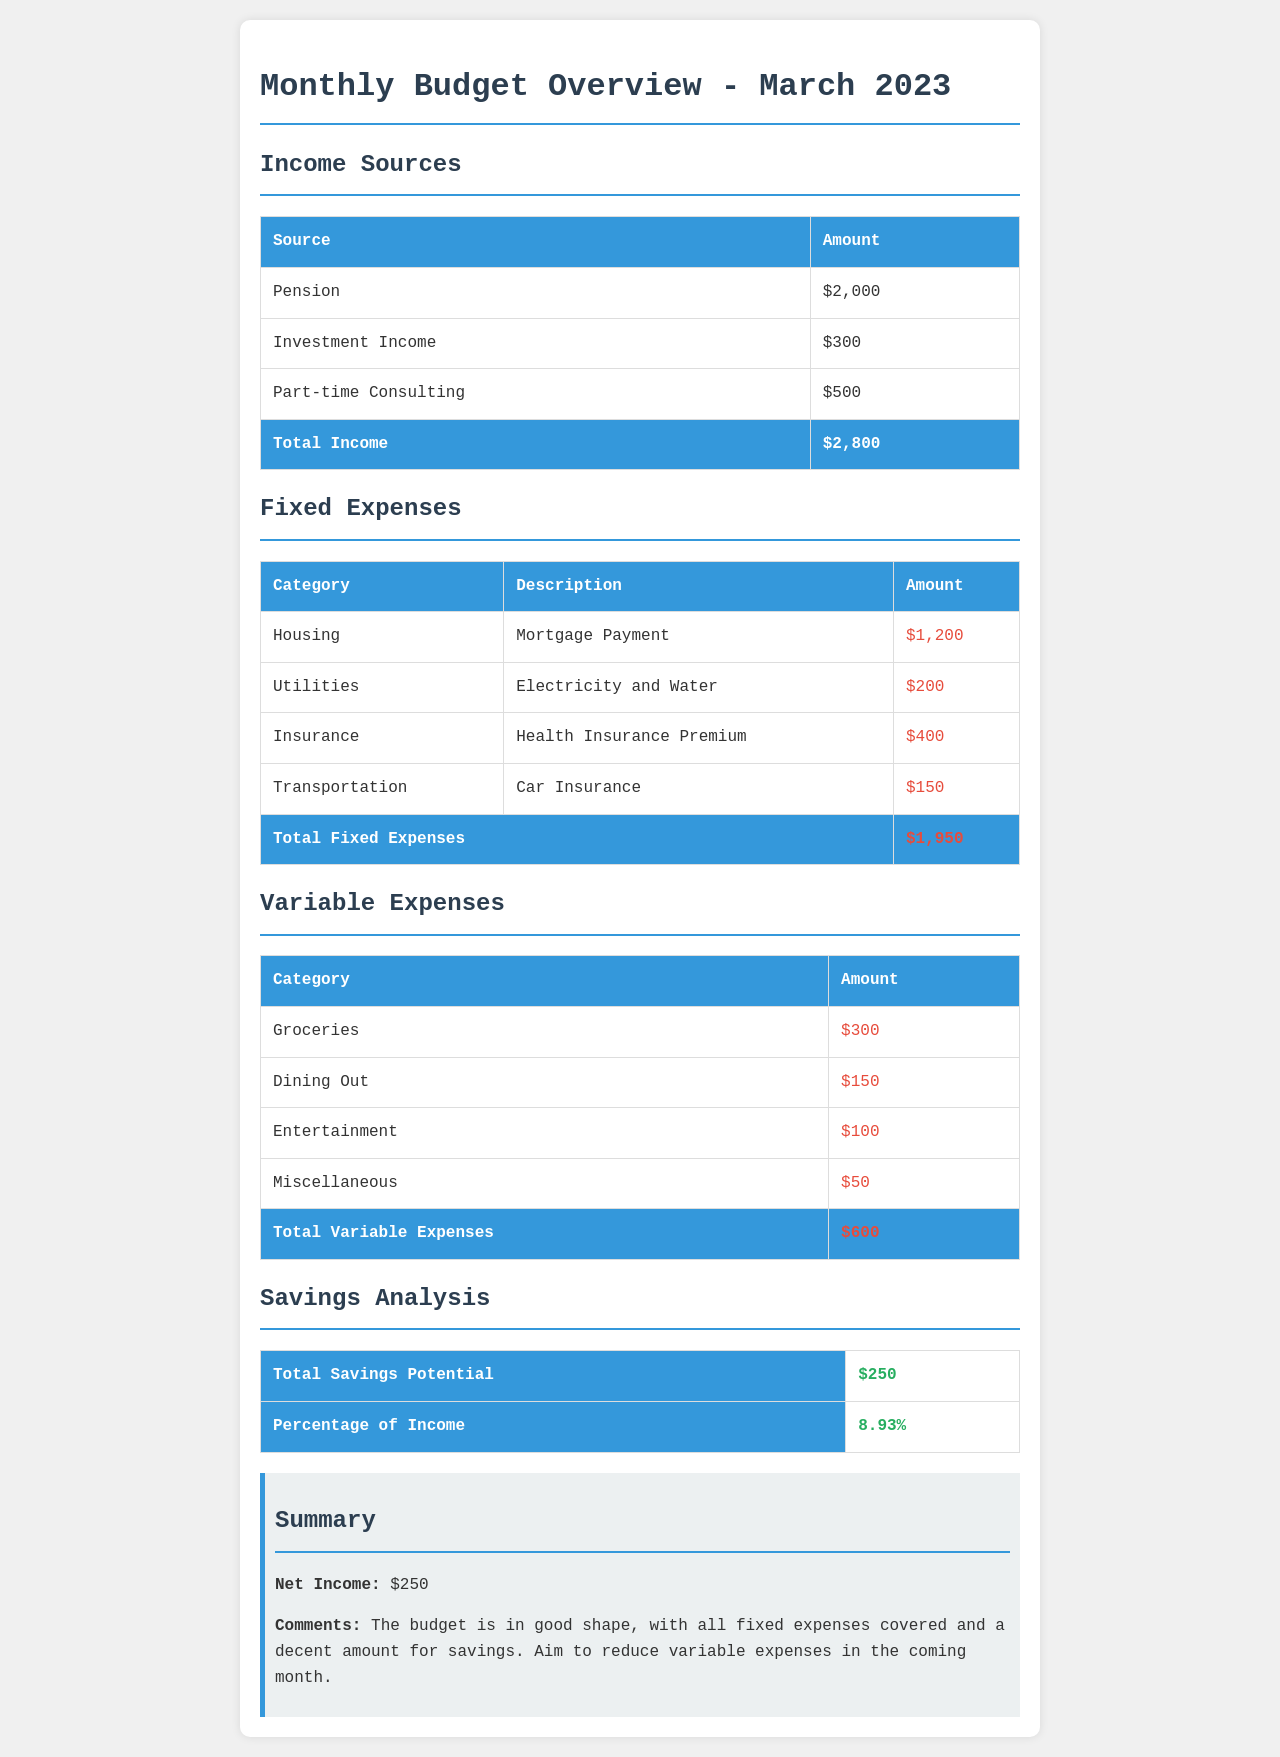What is the total income? The total income is the sum of all income sources in the document, which is $2000 + $300 + $500 = $2800.
Answer: $2800 What are the total fixed expenses? The total fixed expenses is the sum of all fixed expenses listed, which amounts to $1200 + $200 + $400 + $150 = $1950.
Answer: $1950 How much was spent on groceries? The document lists groceries as a variable expense with an amount of $300.
Answer: $300 What is the total savings potential? The document states that the total savings potential is $250.
Answer: $250 What is the percentage of income allocated to savings? The percentage of income for savings, as mentioned in the savings analysis, is 8.93%.
Answer: 8.93% What is the net income for March 2023? The net income is calculated by subtracting total expenses from total income, resulting in $2800 - ($1950 + $600) = $250.
Answer: $250 What comments are provided in the summary? The comments in the summary mention that the budget is in good shape and suggests aiming to reduce variable expenses.
Answer: The budget is in good shape, with all fixed expenses covered and a decent amount for savings. Aim to reduce variable expenses in the coming month What category has the highest fixed expense? The highest fixed expense is the mortgage payment under the housing category at $1200.
Answer: Mortgage Payment 